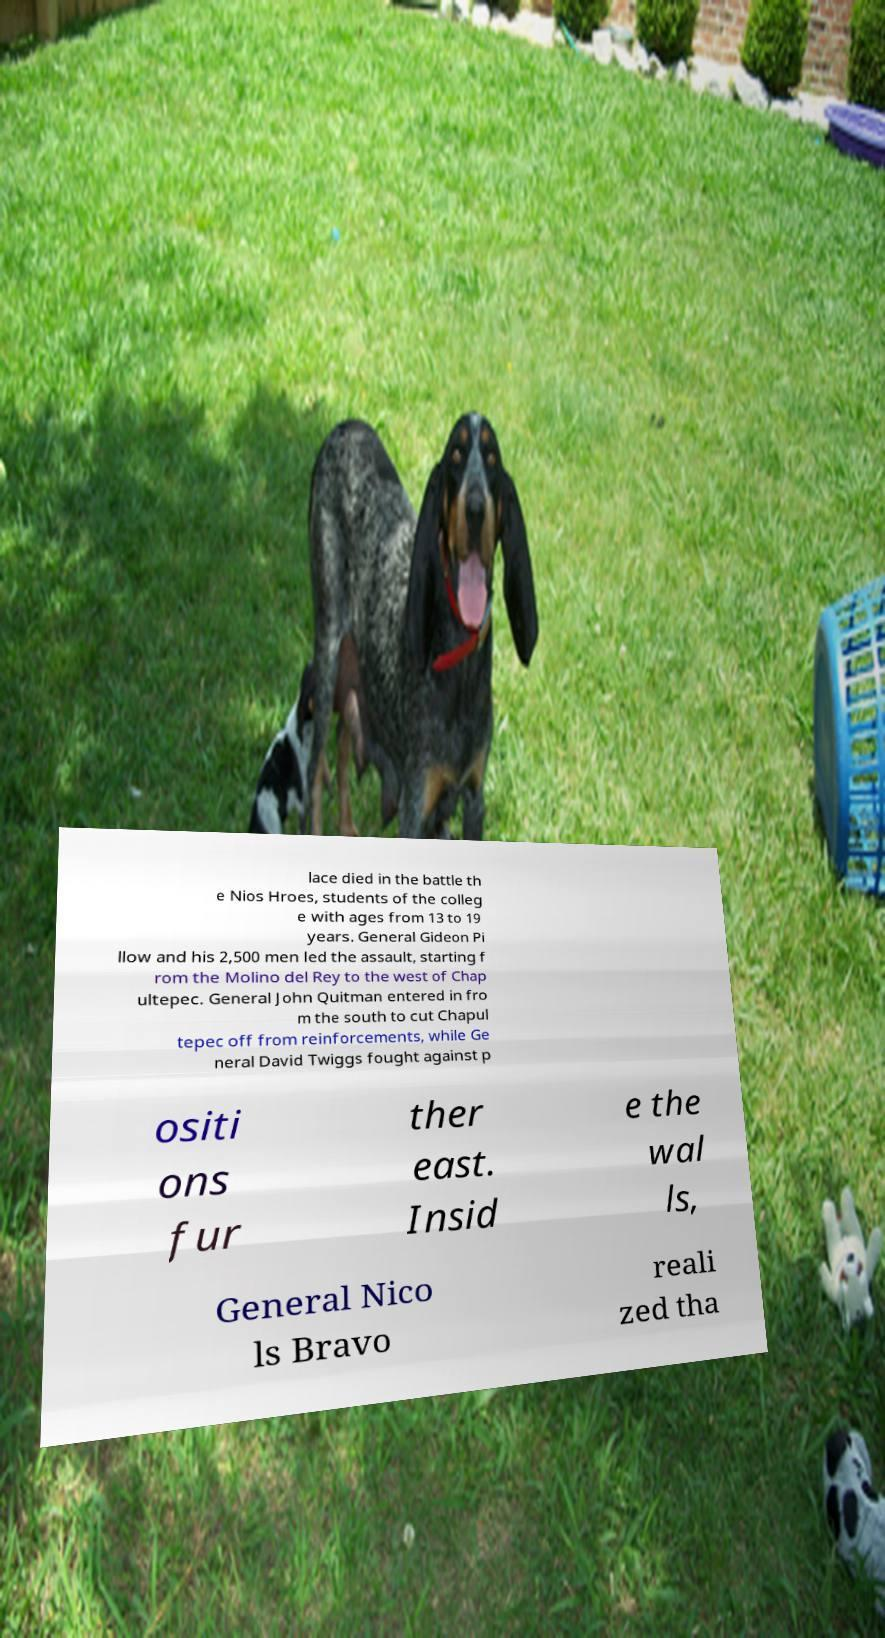I need the written content from this picture converted into text. Can you do that? lace died in the battle th e Nios Hroes, students of the colleg e with ages from 13 to 19 years. General Gideon Pi llow and his 2,500 men led the assault, starting f rom the Molino del Rey to the west of Chap ultepec. General John Quitman entered in fro m the south to cut Chapul tepec off from reinforcements, while Ge neral David Twiggs fought against p ositi ons fur ther east. Insid e the wal ls, General Nico ls Bravo reali zed tha 